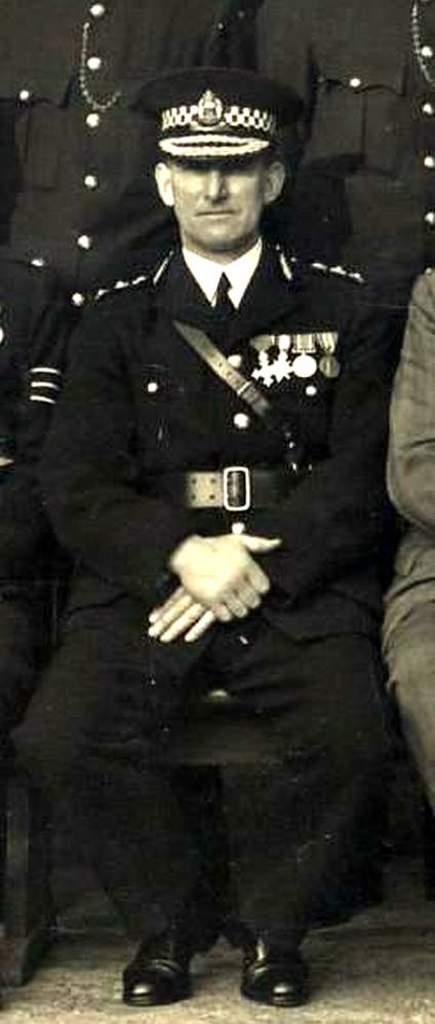Describe this image in one or two sentences. In the middle of the image a man is sitting on the chair. At the bottom of the image there is a floor. On the left and right sides of the image two persons are sitting on the chairs. In the background two men are standing. 